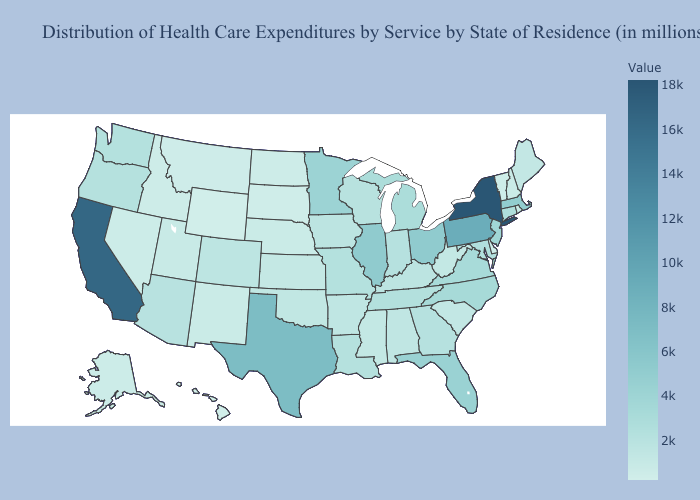Among the states that border Utah , which have the highest value?
Short answer required. Arizona. Does Missouri have a higher value than Ohio?
Give a very brief answer. No. Among the states that border South Dakota , does Montana have the lowest value?
Short answer required. No. Does Louisiana have a lower value than South Dakota?
Be succinct. No. Does Washington have a lower value than Vermont?
Write a very short answer. No. Is the legend a continuous bar?
Concise answer only. Yes. Which states hav the highest value in the South?
Answer briefly. Texas. Which states have the highest value in the USA?
Concise answer only. New York. Does Arkansas have the highest value in the USA?
Write a very short answer. No. 